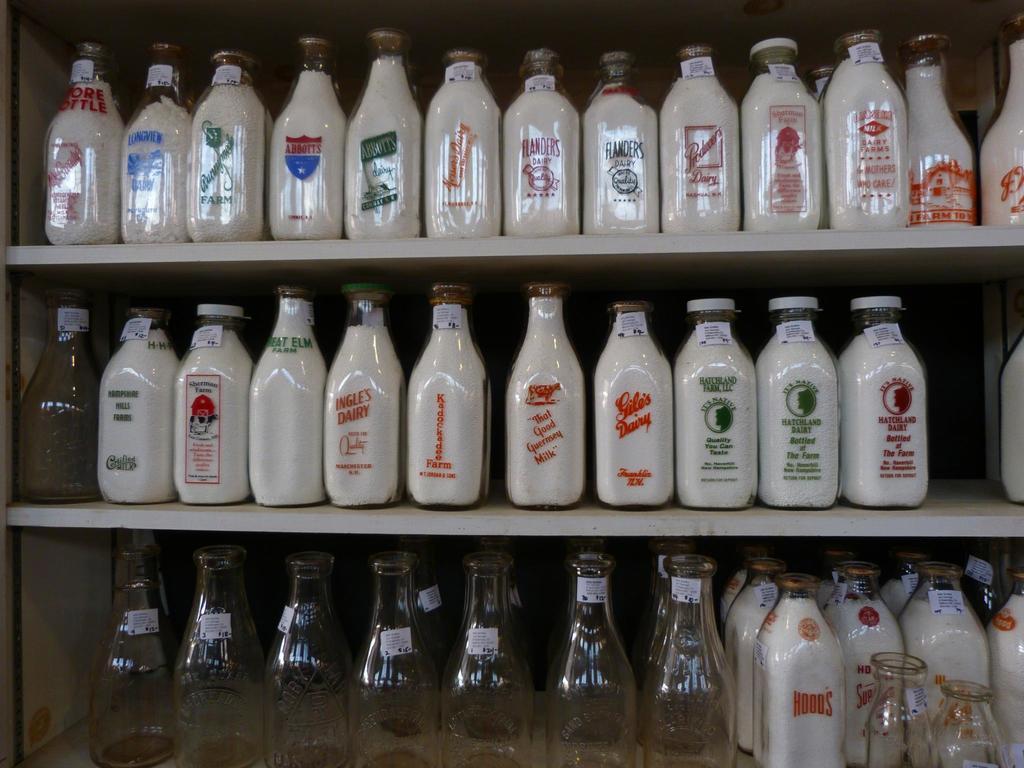What is one of the brands shown?
Offer a terse response. Hood's. What kind of drink is for sale?
Give a very brief answer. Milk. 